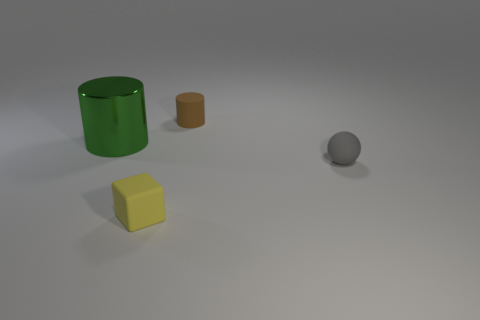Is there anything else that has the same shape as the tiny yellow matte thing?
Ensure brevity in your answer.  No. The cylinder that is on the right side of the matte thing that is to the left of the cylinder that is right of the small yellow block is what color?
Ensure brevity in your answer.  Brown. What number of big things are balls or yellow cubes?
Your answer should be very brief. 0. Are there the same number of matte things that are in front of the tiny brown object and cylinders?
Give a very brief answer. Yes. There is a large cylinder; are there any rubber cubes in front of it?
Provide a succinct answer. Yes. How many metal objects are tiny brown things or tiny cubes?
Provide a succinct answer. 0. There is a tiny brown cylinder; how many objects are in front of it?
Provide a succinct answer. 3. Is there a yellow metal block of the same size as the brown thing?
Your answer should be compact. No. Is there anything else that has the same size as the green cylinder?
Your response must be concise. No. What number of things are large purple matte cylinders or things that are on the right side of the small brown rubber object?
Make the answer very short. 1. 